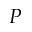<formula> <loc_0><loc_0><loc_500><loc_500>P</formula> 